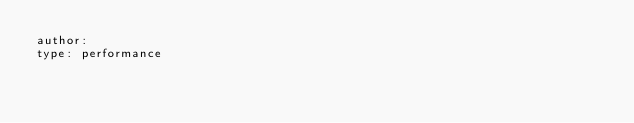Convert code to text. <code><loc_0><loc_0><loc_500><loc_500><_YAML_>author:
type: performance
</code> 